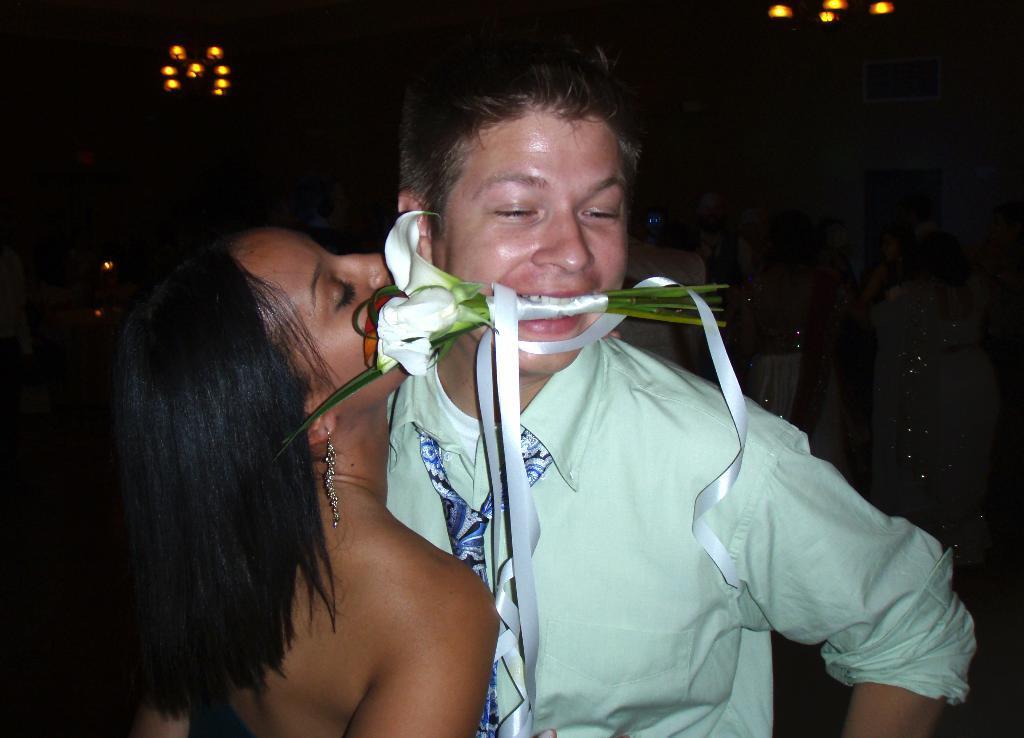In one or two sentences, can you explain what this image depicts? In the image we can see there are people standing. There is a man holding a flower bouquet in his mouth and he is wearing a tie. 